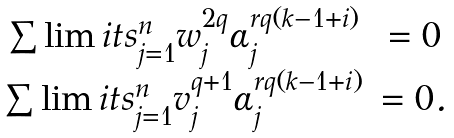Convert formula to latex. <formula><loc_0><loc_0><loc_500><loc_500>\begin{array} { c c } \sum \lim i t s _ { j = 1 } ^ { n } w _ { j } ^ { 2 q } \alpha _ { j } ^ { r q ( k - 1 + i ) } & = 0 \\ \sum \lim i t s _ { j = 1 } ^ { n } v _ { j } ^ { q + 1 } \alpha _ { j } ^ { r q ( k - 1 + i ) } & = 0 . \\ \end{array}</formula> 